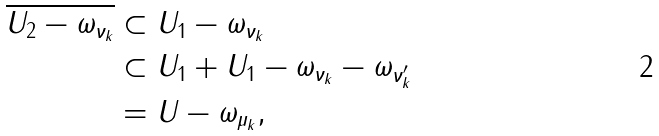Convert formula to latex. <formula><loc_0><loc_0><loc_500><loc_500>\overline { U _ { 2 } - \omega _ { \nu _ { k } } } & \subset U _ { 1 } - \omega _ { \nu _ { k } } \\ & \subset U _ { 1 } + U _ { 1 } - \omega _ { \nu _ { k } } - \omega _ { \nu _ { k } ^ { \prime } } \\ & = U - \omega _ { \mu _ { k } } ,</formula> 